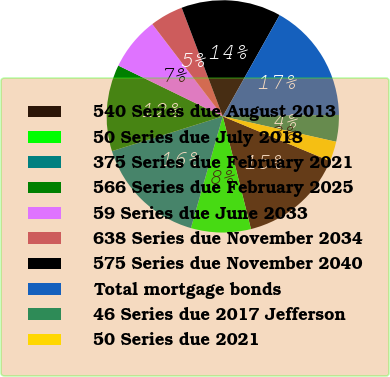Convert chart to OTSL. <chart><loc_0><loc_0><loc_500><loc_500><pie_chart><fcel>540 Series due August 2013<fcel>50 Series due July 2018<fcel>375 Series due February 2021<fcel>566 Series due February 2025<fcel>59 Series due June 2033<fcel>638 Series due November 2034<fcel>575 Series due November 2040<fcel>Total mortgage bonds<fcel>46 Series due 2017 Jefferson<fcel>50 Series due 2021<nl><fcel>14.81%<fcel>8.33%<fcel>15.74%<fcel>12.04%<fcel>7.41%<fcel>4.63%<fcel>13.89%<fcel>16.67%<fcel>3.7%<fcel>2.78%<nl></chart> 